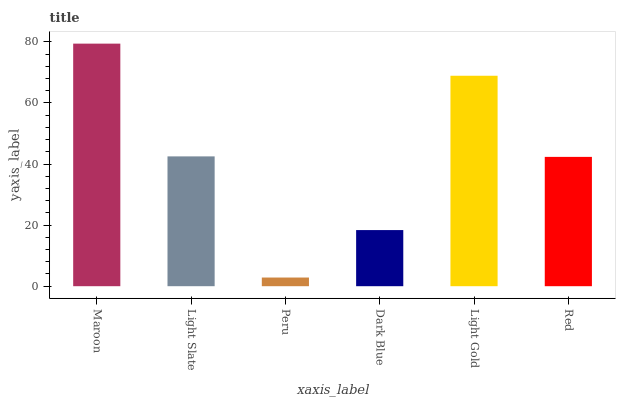Is Peru the minimum?
Answer yes or no. Yes. Is Maroon the maximum?
Answer yes or no. Yes. Is Light Slate the minimum?
Answer yes or no. No. Is Light Slate the maximum?
Answer yes or no. No. Is Maroon greater than Light Slate?
Answer yes or no. Yes. Is Light Slate less than Maroon?
Answer yes or no. Yes. Is Light Slate greater than Maroon?
Answer yes or no. No. Is Maroon less than Light Slate?
Answer yes or no. No. Is Light Slate the high median?
Answer yes or no. Yes. Is Red the low median?
Answer yes or no. Yes. Is Red the high median?
Answer yes or no. No. Is Light Slate the low median?
Answer yes or no. No. 